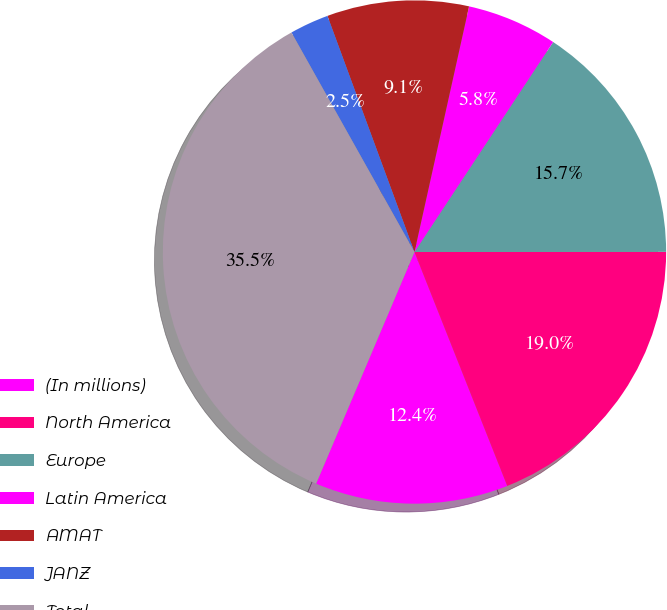Convert chart to OTSL. <chart><loc_0><loc_0><loc_500><loc_500><pie_chart><fcel>(In millions)<fcel>North America<fcel>Europe<fcel>Latin America<fcel>AMAT<fcel>JANZ<fcel>Total<nl><fcel>12.4%<fcel>19.0%<fcel>15.7%<fcel>5.81%<fcel>9.1%<fcel>2.51%<fcel>35.48%<nl></chart> 